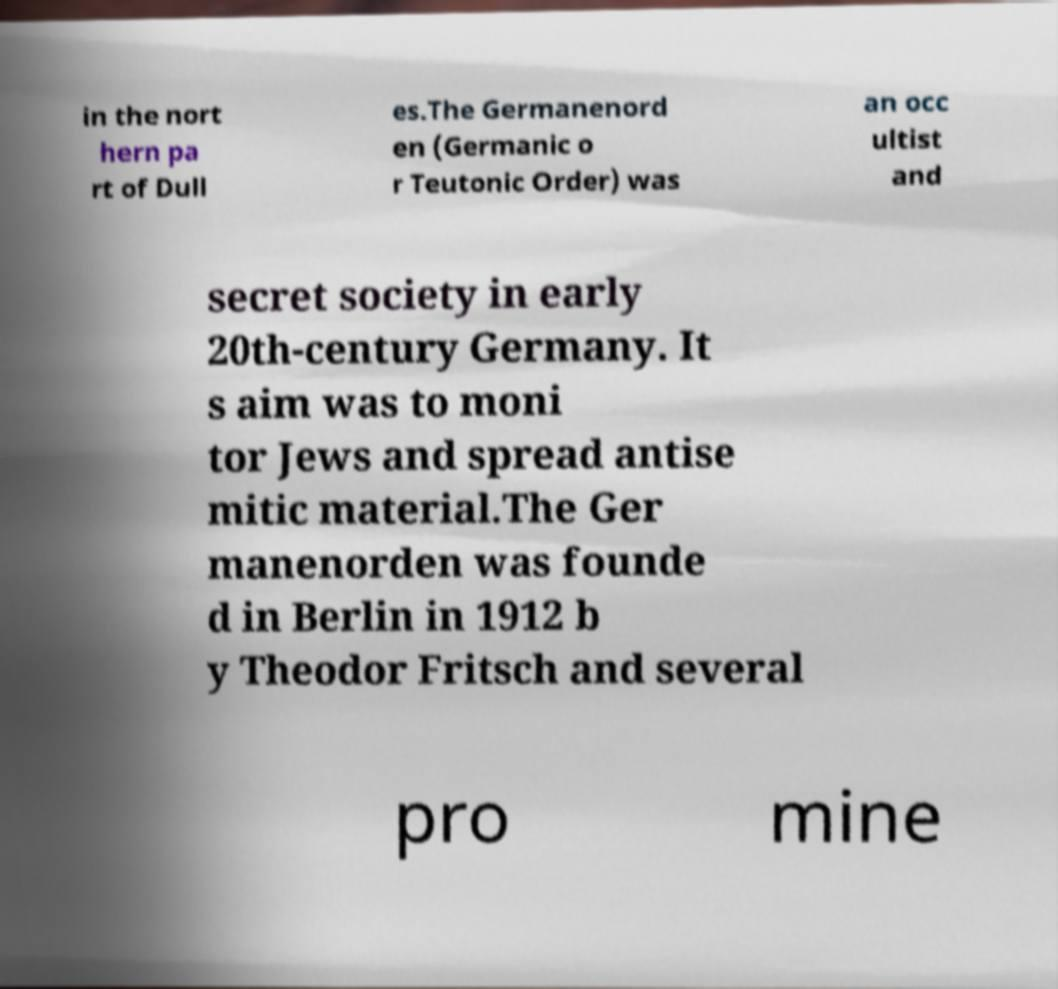Can you read and provide the text displayed in the image?This photo seems to have some interesting text. Can you extract and type it out for me? in the nort hern pa rt of Dull es.The Germanenord en (Germanic o r Teutonic Order) was an occ ultist and secret society in early 20th-century Germany. It s aim was to moni tor Jews and spread antise mitic material.The Ger manenorden was founde d in Berlin in 1912 b y Theodor Fritsch and several pro mine 